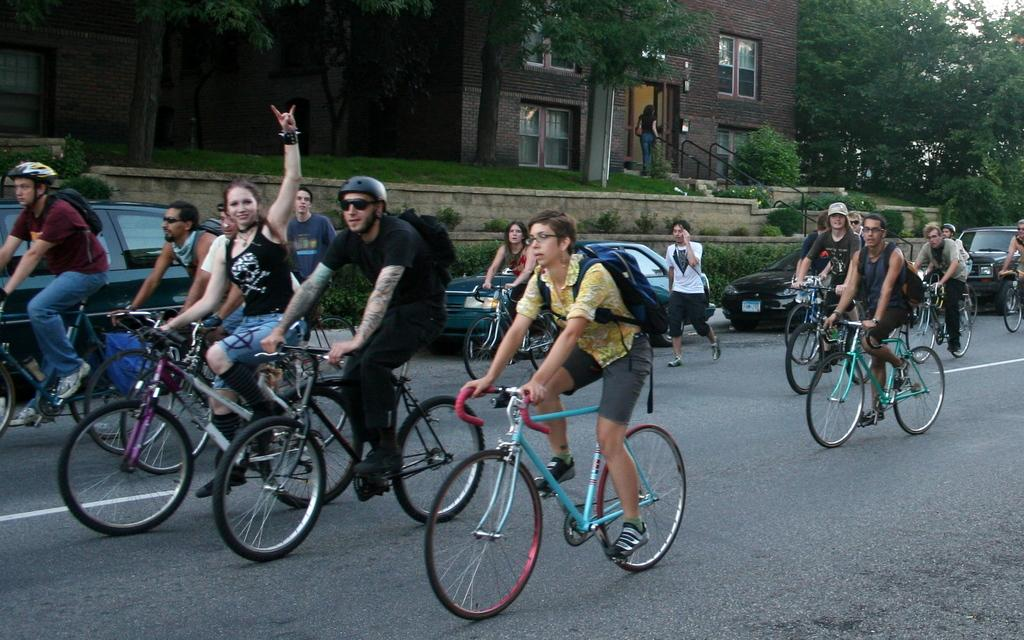What types of transportation can be seen in the image? There are motor vehicles parked on the road and persons sitting on bicycles. What are the people on the road doing? There are persons walking on the road. What architectural feature is present in the image? There is a staircase in the image. What safety feature is present in the image? There are railings in the image. What structures are visible in the image? There are buildings in the image. What part of the buildings can be seen? There are windows visible in the image. What natural elements are present in the image? There are trees in the image. What part of the natural environment is visible in the image? The sky is visible in the image. What type of iron is being used to protest in the image? There is no protest or iron present in the image. Can you see any cows grazing in the image? There are no cows present in the image. 